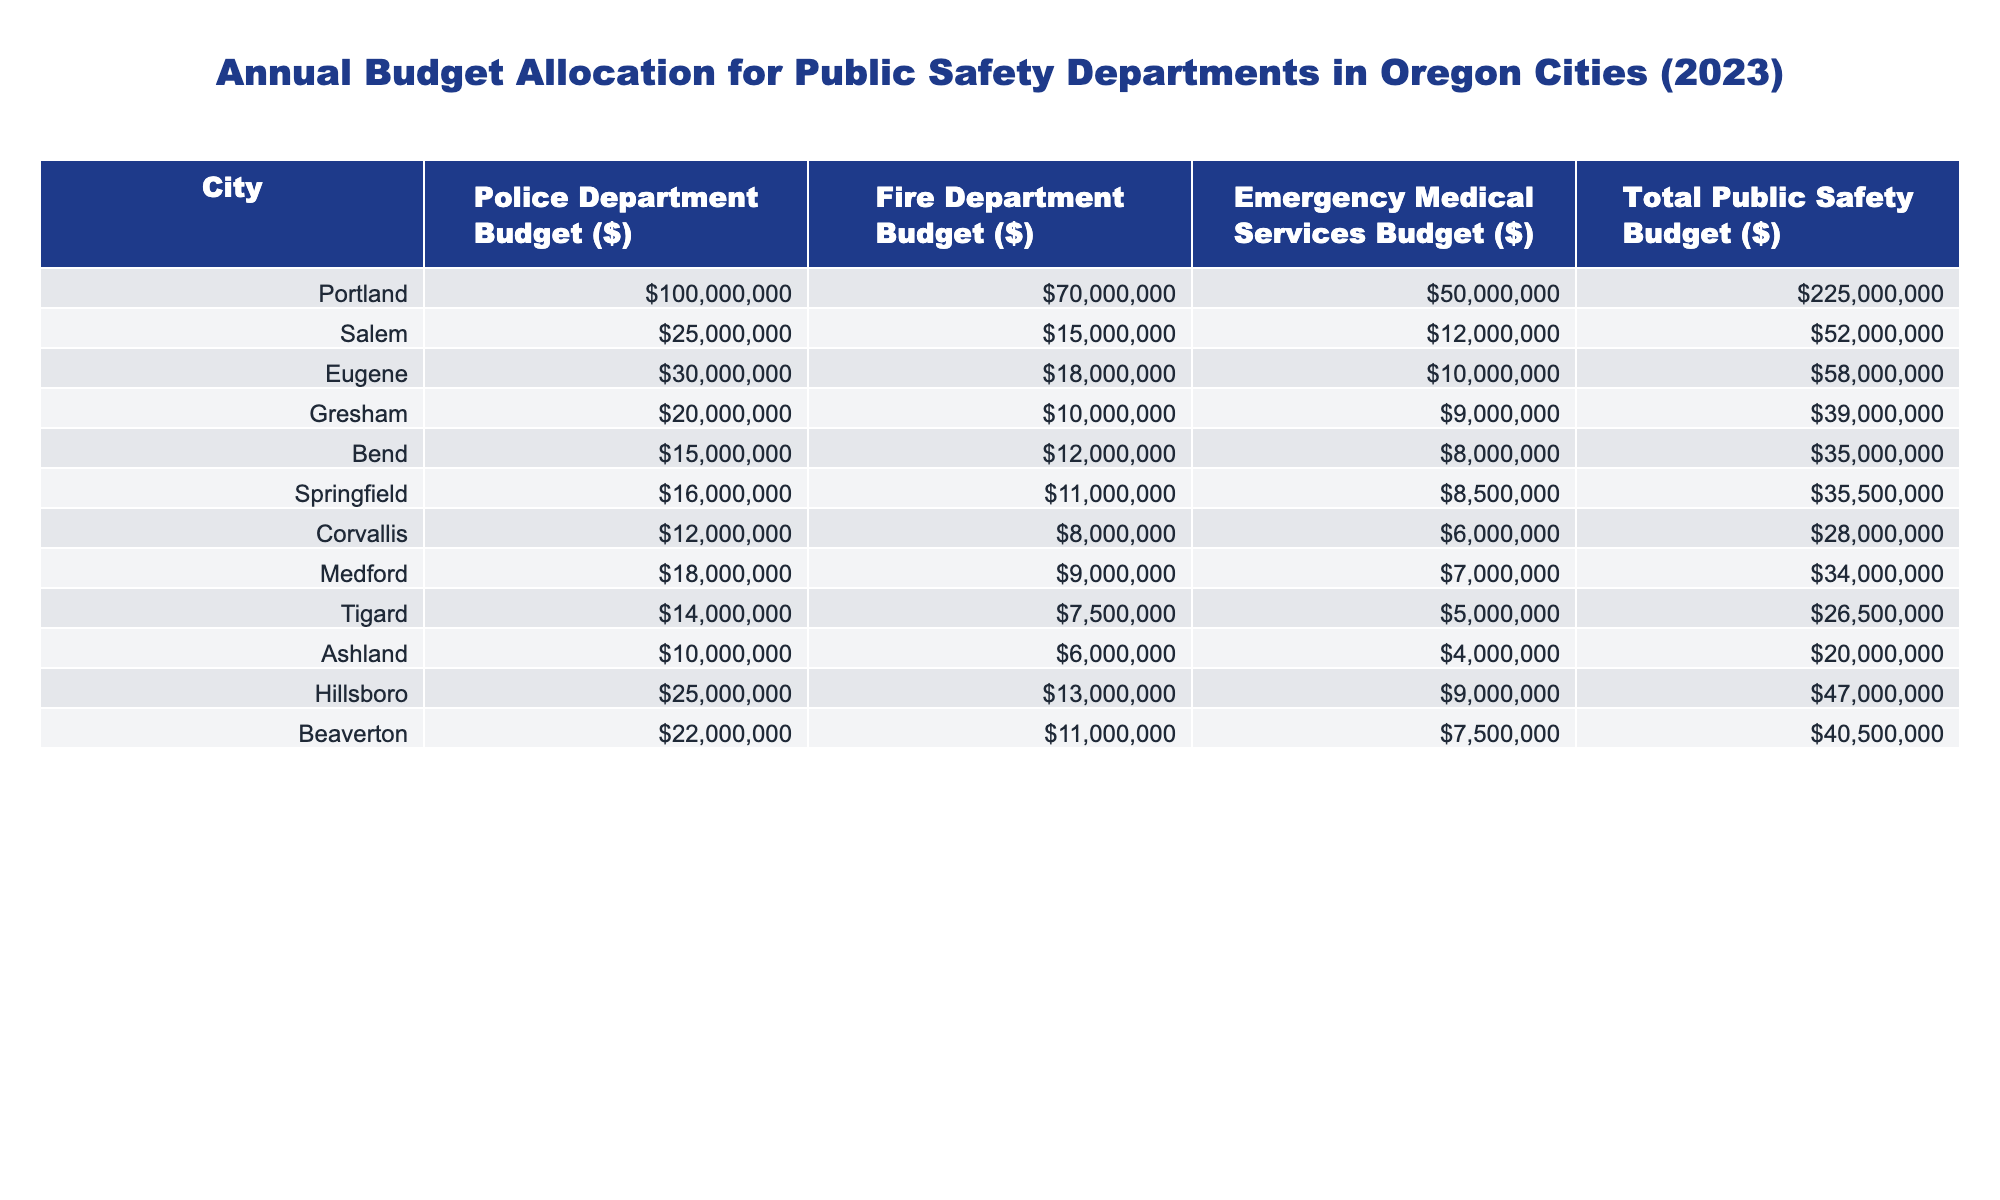What is the total public safety budget for Salem? The table shows that Salem has a total public safety budget of $52,000,000.
Answer: $52,000,000 Which city has the highest police department budget? According to the table, Portland has the highest police department budget at $100,000,000.
Answer: Portland What is the combined budget for the fire and emergency medical services departments in Eugene? In Eugene, the fire department budget is $18,000,000 and the EMS budget is $10,000,000. Adding these gives $18,000,000 + $10,000,000 = $28,000,000.
Answer: $28,000,000 Is the fire department budget for Hillsboro greater than the total public safety budget for Ashland? Hillsboro has a fire department budget of $13,000,000, while Ashland's total public safety budget is $20,000,000. Since $13,000,000 is less than $20,000,000, the statement is false.
Answer: No Calculate the average total public safety budget across all cities listed. The total public safety budgets for all cities are: Portland ($225M), Salem ($52M), Eugene ($58M), Gresham ($39M), Bend ($35M), Springfield ($35.5M), Corvallis ($28M), Medford ($34M), Tigard ($26.5M), Ashland ($20M), Hillsboro ($47M), and Beaverton ($40.5M). The sum is $225 + 52 + 58 + 39 + 35 + 35.5 + 28 + 34 + 26.5 + 20 + 47 + 40.5 = $720M. There are 12 cities, so the average is $720M / 12 = $60M.
Answer: $60M What is the difference between the police department budget in Gresham and Bend? Gresham has a police department budget of $20,000,000, while Bend has a budget of $15,000,000. The difference is $20,000,000 - $15,000,000 = $5,000,000.
Answer: $5,000,000 Which city's total public safety budget is closest to $30,000,000? By examining the table, Corvallis has a total public safety budget of $28,000,000, which is the closest to $30,000,000.
Answer: Corvallis Does Eugene spend more on their fire department than on emergency medical services? Eugene's fire department budget is $18,000,000 and their EMS budget is $10,000,000. Since $18,000,000 is greater than $10,000,000, the statement is true.
Answer: Yes What is the total amount allocated to fire departments across all cities? The total fire department budgets for all cities sum up to: $70,000,000 (Portland) + $15,000,000 (Salem) + $18,000,000 (Eugene) + $10,000,000 (Gresham) + $12,000,000 (Bend) + $11,000,000 (Springfield) + $8,000,000 (Corvallis) + $9,000,000 (Medford) + $7,500,000 (Tigard) + $6,000,000 (Ashland) + $13,000,000 (Hillsboro) + $11,000,000 (Beaverton) = $305,500,000.
Answer: $305,500,000 Which city has the smallest total public safety budget? By looking at the table, Ashland has the smallest total public safety budget at $20,000,000.
Answer: Ashland 